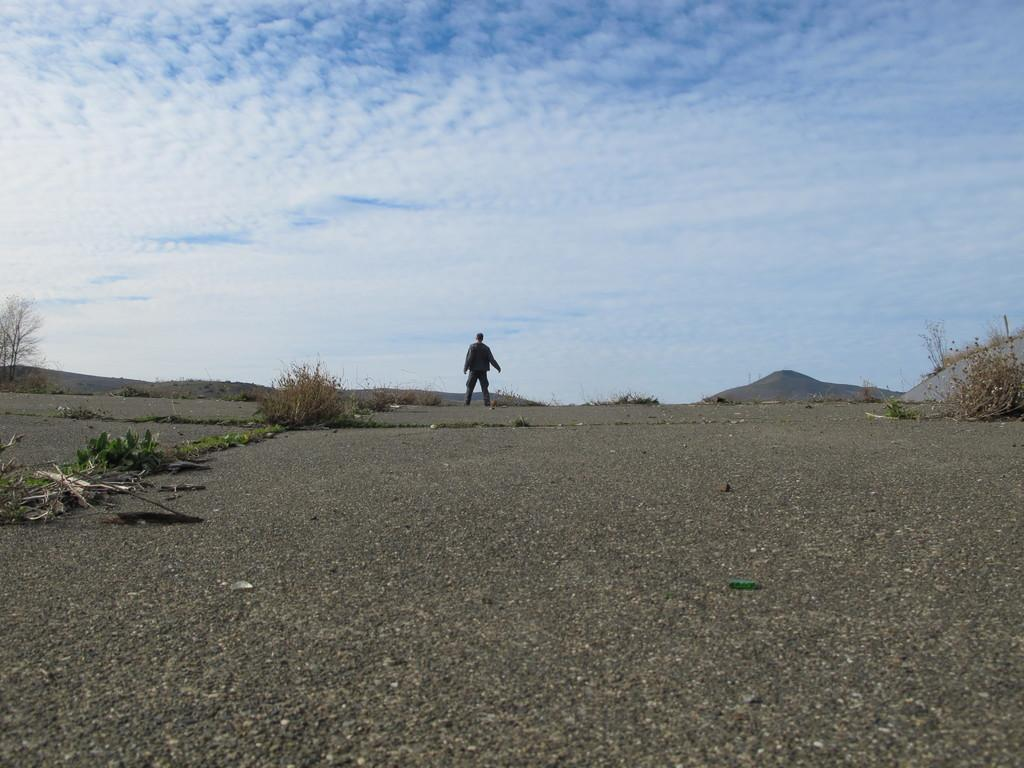What type of living organisms can be seen in the image? Plants can be seen in the image. Where is the person located in the image? The person is standing in the middle of the image. What can be seen in the background of the image? Hills and clouds are visible in the background of the image. What type of building can be seen in the image? There is no building present in the image. What suggestion does the person in the image have for the viewer? The image does not provide any information about a suggestion from the person. 